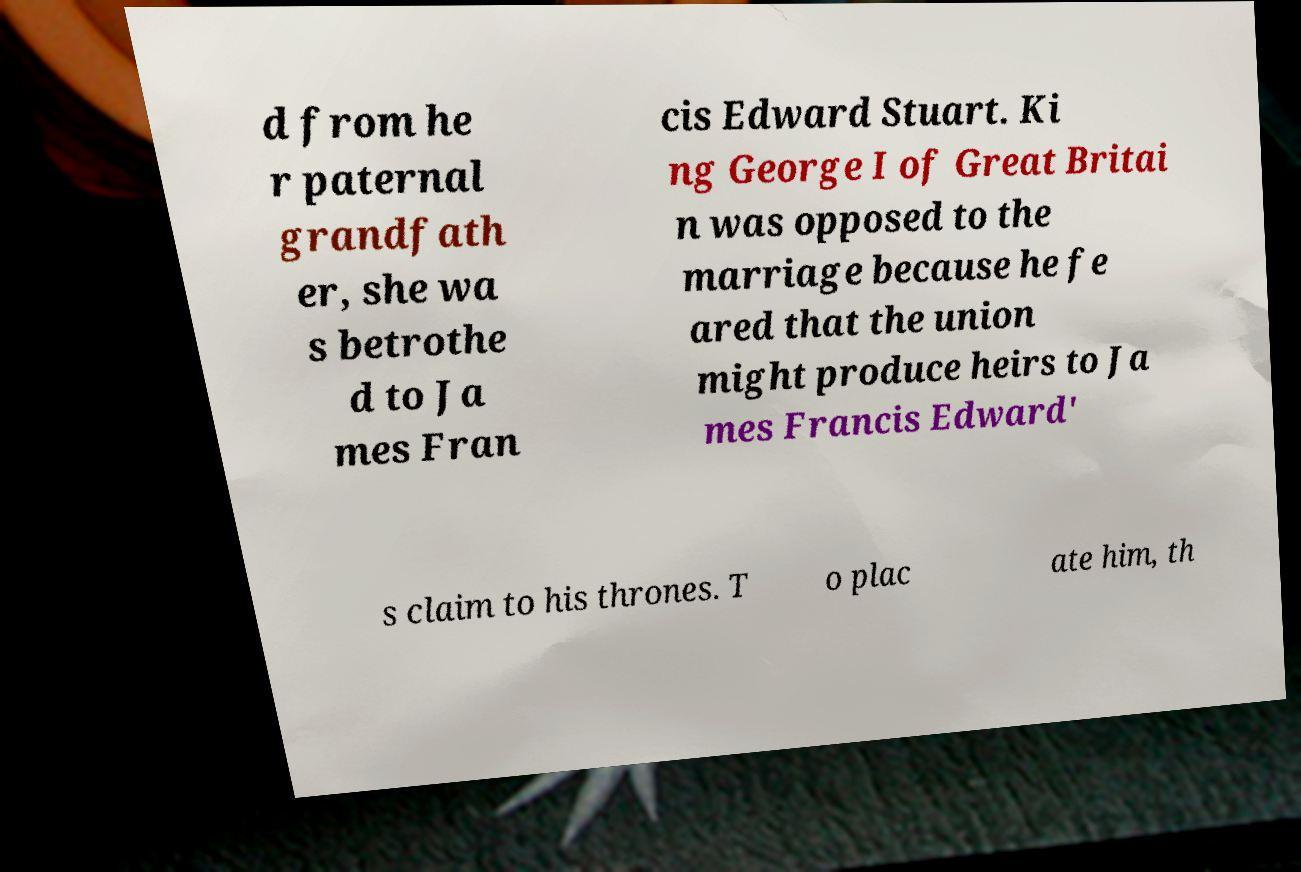Please identify and transcribe the text found in this image. d from he r paternal grandfath er, she wa s betrothe d to Ja mes Fran cis Edward Stuart. Ki ng George I of Great Britai n was opposed to the marriage because he fe ared that the union might produce heirs to Ja mes Francis Edward' s claim to his thrones. T o plac ate him, th 